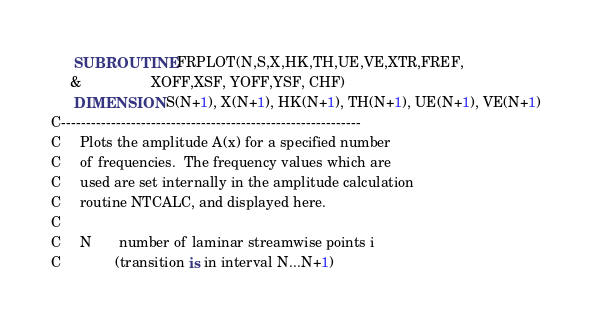<code> <loc_0><loc_0><loc_500><loc_500><_FORTRAN_>
      SUBROUTINE FRPLOT(N,S,X,HK,TH,UE,VE,XTR,FREF,
     &                  XOFF,XSF, YOFF,YSF, CHF)
      DIMENSION S(N+1), X(N+1), HK(N+1), TH(N+1), UE(N+1), VE(N+1)
C------------------------------------------------------------
C     Plots the amplitude A(x) for a specified number 
C     of frequencies.  The frequency values which are 
C     used are set internally in the amplitude calculation
C     routine NTCALC, and displayed here.
C
C     N       number of laminar streamwise points i 
C              (transition is in interval N...N+1)</code> 